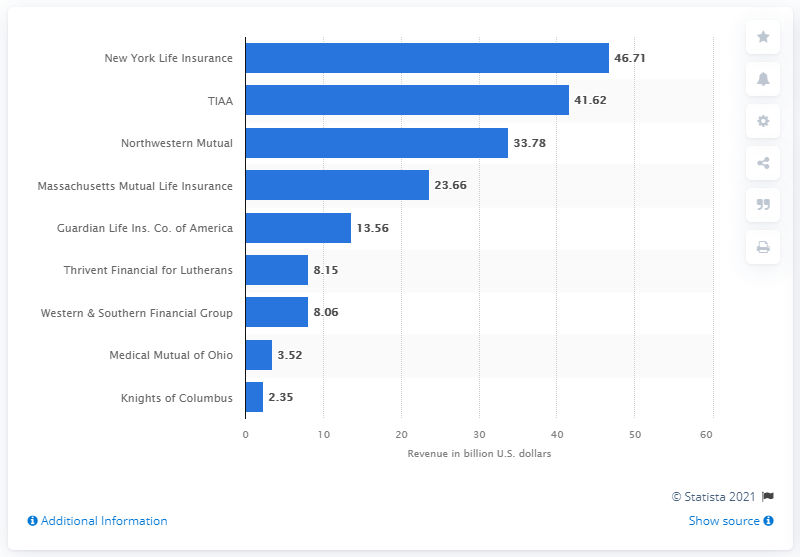Outline some significant characteristics in this image. New York Life Insurance Company's revenue in 2020 was approximately 46.71 billion dollars. 